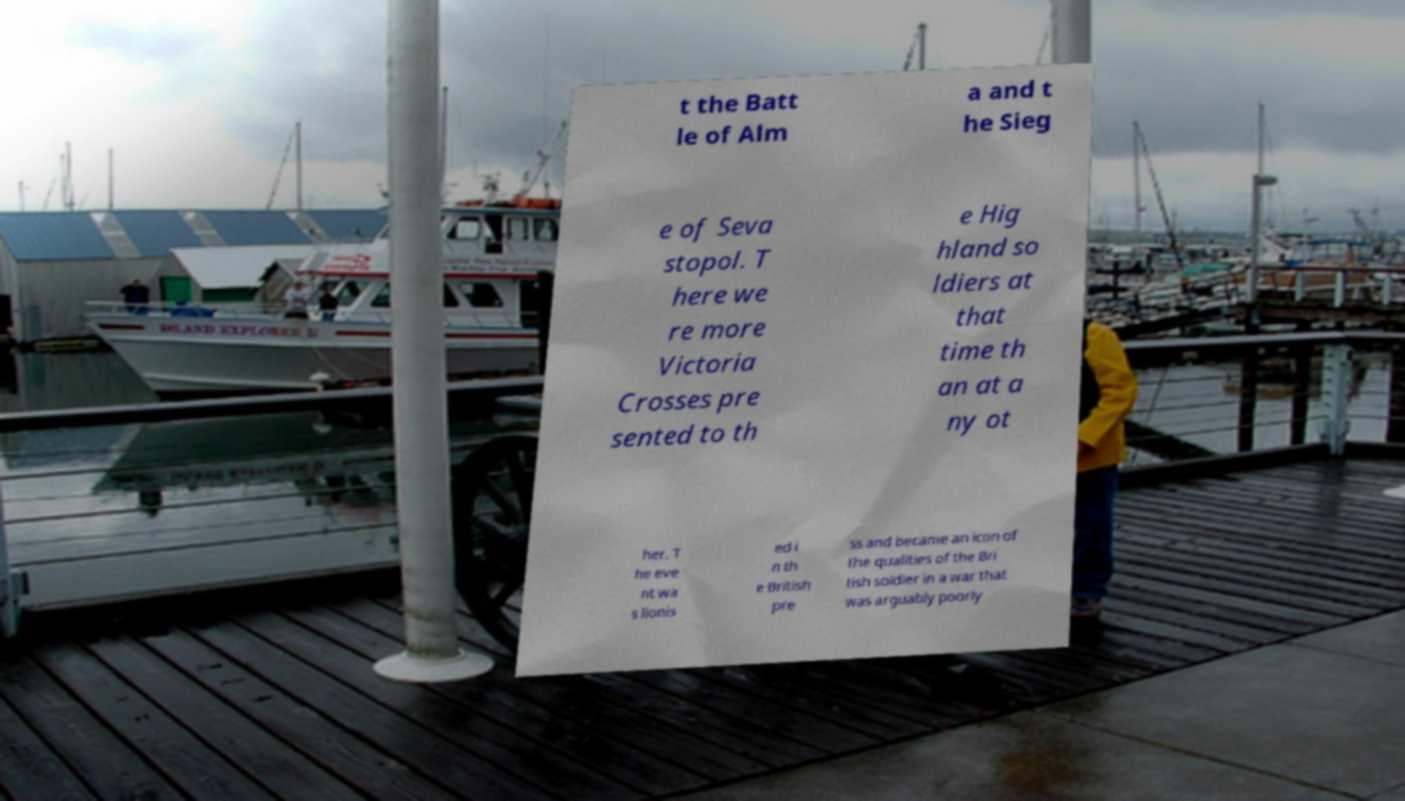Can you accurately transcribe the text from the provided image for me? t the Batt le of Alm a and t he Sieg e of Seva stopol. T here we re more Victoria Crosses pre sented to th e Hig hland so ldiers at that time th an at a ny ot her. T he eve nt wa s lionis ed i n th e British pre ss and became an icon of the qualities of the Bri tish soldier in a war that was arguably poorly 